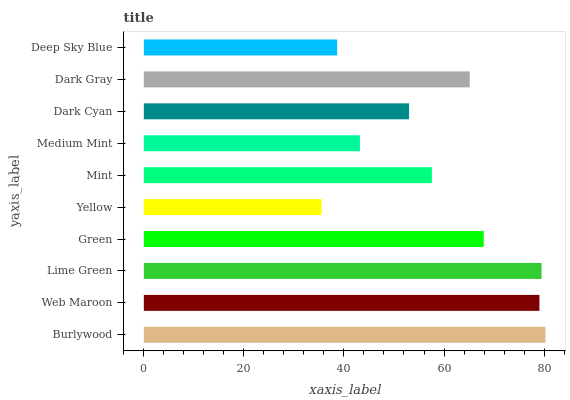Is Yellow the minimum?
Answer yes or no. Yes. Is Burlywood the maximum?
Answer yes or no. Yes. Is Web Maroon the minimum?
Answer yes or no. No. Is Web Maroon the maximum?
Answer yes or no. No. Is Burlywood greater than Web Maroon?
Answer yes or no. Yes. Is Web Maroon less than Burlywood?
Answer yes or no. Yes. Is Web Maroon greater than Burlywood?
Answer yes or no. No. Is Burlywood less than Web Maroon?
Answer yes or no. No. Is Dark Gray the high median?
Answer yes or no. Yes. Is Mint the low median?
Answer yes or no. Yes. Is Yellow the high median?
Answer yes or no. No. Is Green the low median?
Answer yes or no. No. 